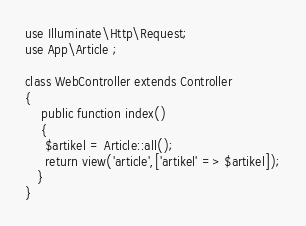Convert code to text. <code><loc_0><loc_0><loc_500><loc_500><_PHP_>use Illuminate\Http\Request; 
use App\Article ;

class WebController extends Controller
{
    public function index()
    {
   	 $artikel = Article::all();
     return view('article',['artikel' => $artikel]);
   }
}
</code> 